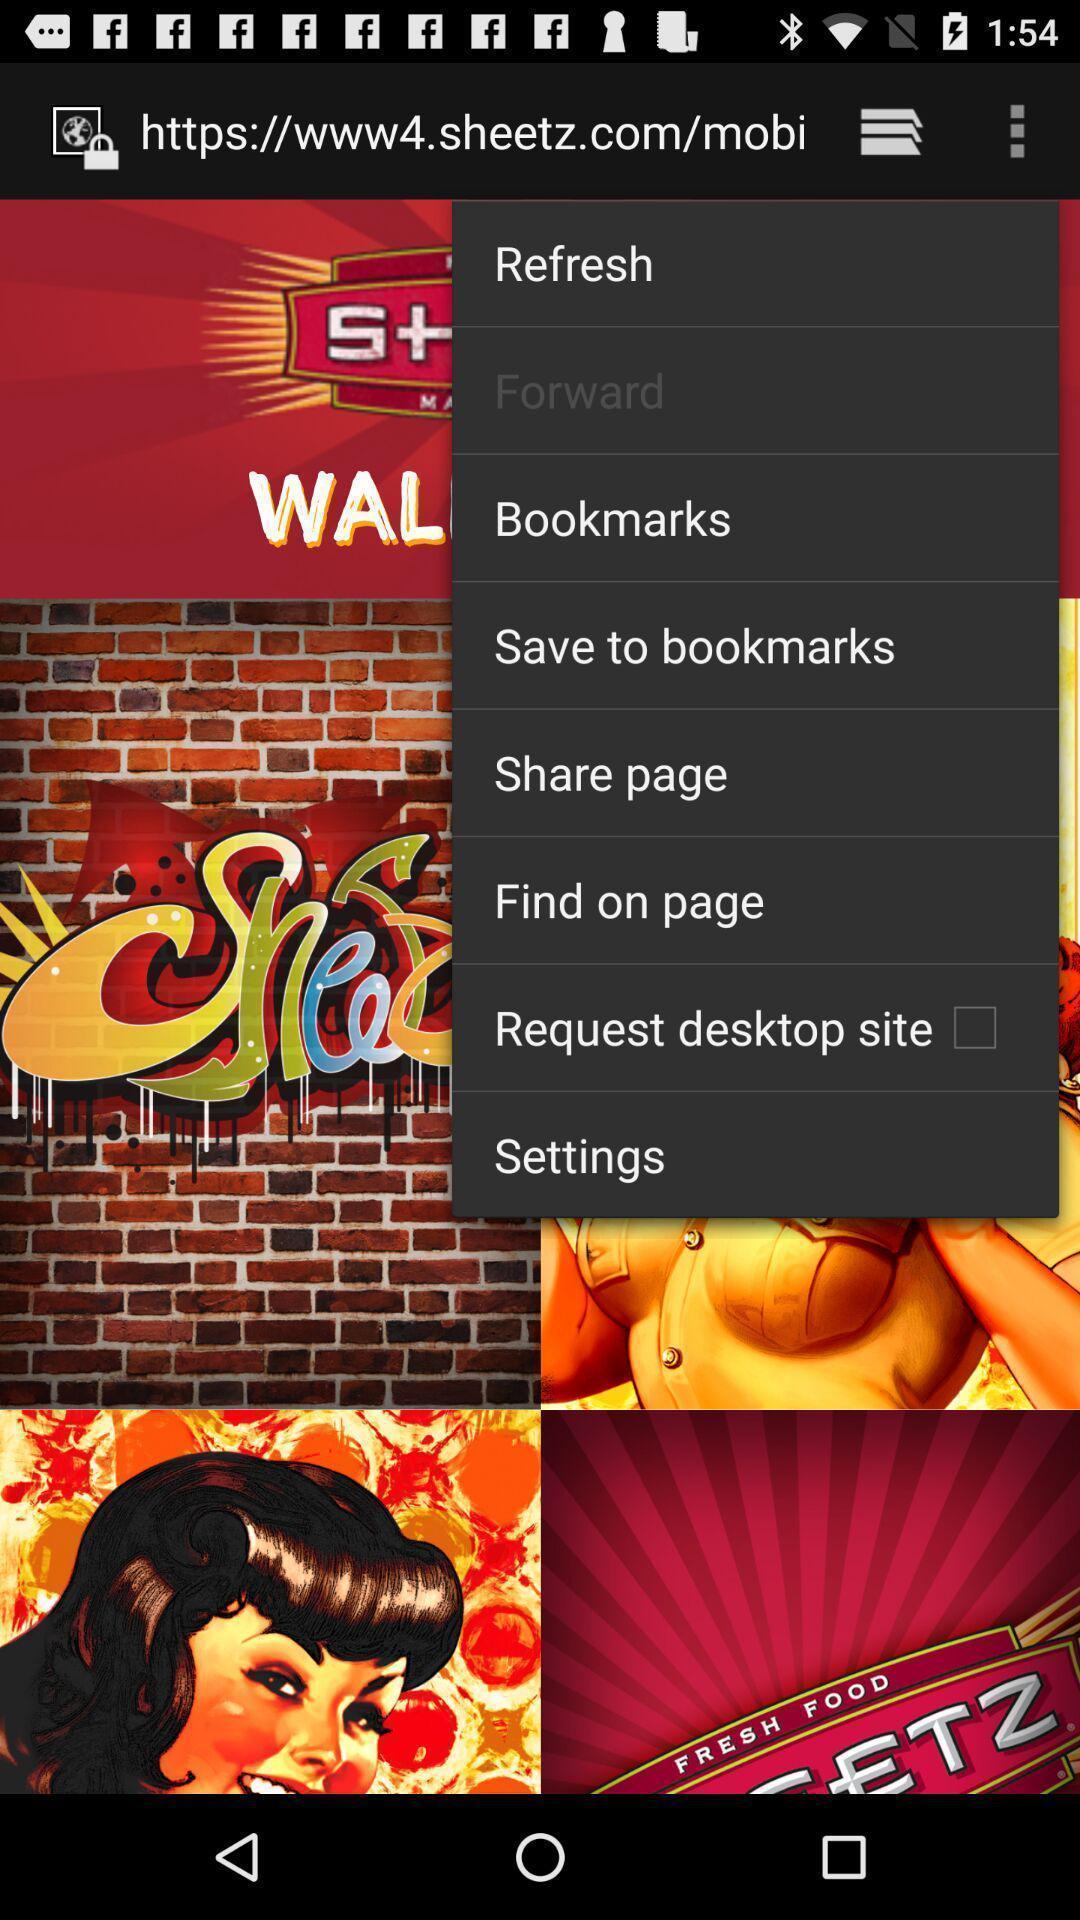Please provide a description for this image. Screen displaying list of options in app. 